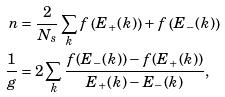<formula> <loc_0><loc_0><loc_500><loc_500>n & = \frac { 2 } { N _ { s } } \sum _ { k } f \left ( E _ { + } ( k ) \right ) + f \left ( E _ { - } ( k ) \right ) \\ \frac { 1 } { g } & = 2 \sum _ { k } \frac { f ( E _ { - } ( k ) ) - f ( E _ { + } ( k ) ) } { E _ { + } ( k ) - E _ { - } ( k ) } ,</formula> 